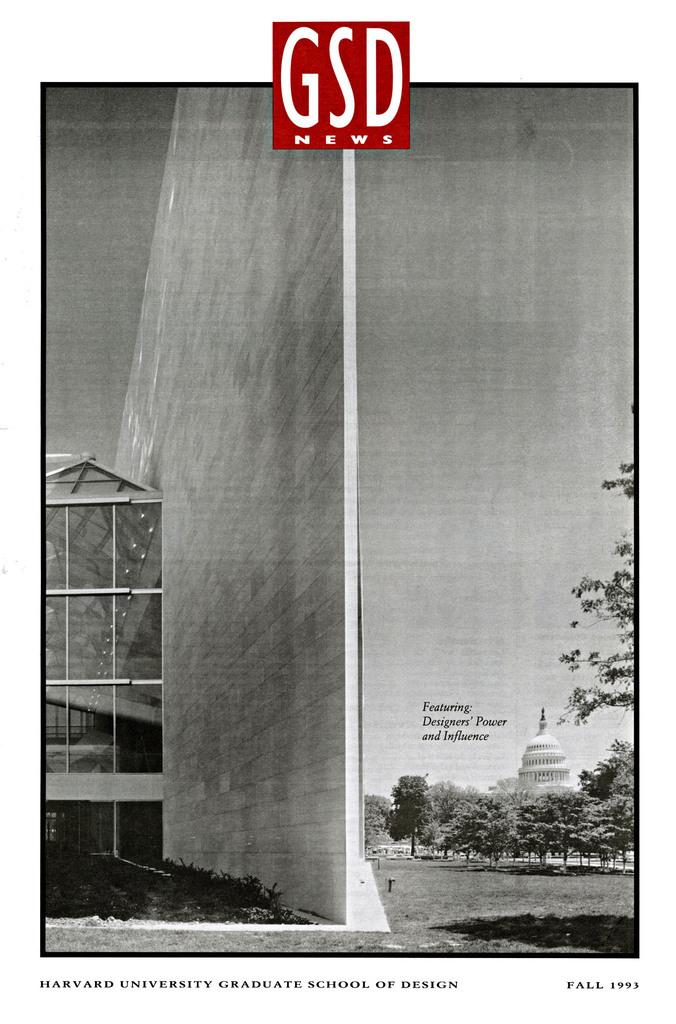What type of picture is in the image? There is a collage picture in the image. What structures can be seen in the collage picture? Buildings are visible in the image. What type of vegetation is present in the image? There are trees in the image. What is the color scheme of the image? The image is in black and white. Where is the cobweb located in the image? There is no cobweb present in the image. What is the cause of the buildings in the image? The cause of the buildings in the image cannot be determined from the image itself. 